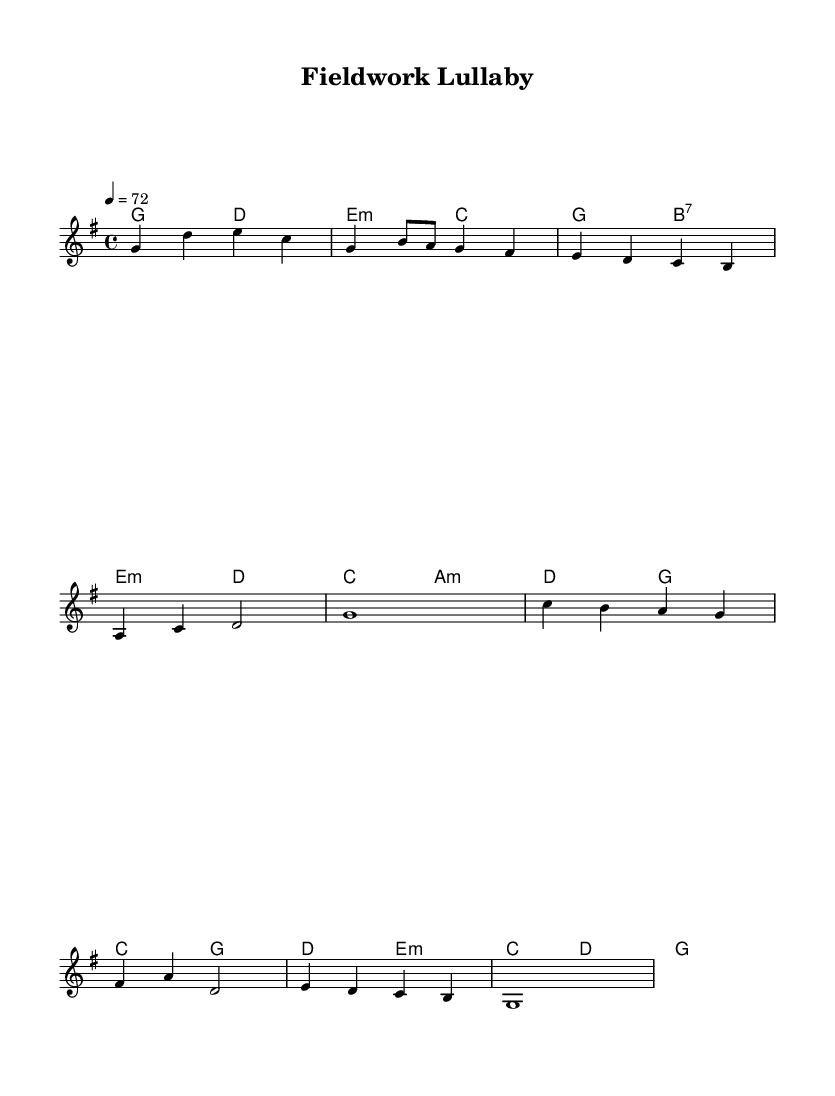What is the key signature of this music? The key signature is G major, which has one sharp (F#).
Answer: G major What is the time signature of this piece? The time signature is 4/4, meaning there are four beats per measure and a quarter note receives one beat.
Answer: 4/4 What is the tempo marking for this piece? The tempo marking is 72 beats per minute, indicating a moderate tempo.
Answer: 72 How many measures are in the chorus section? The chorus section consists of four measures, as indicated by the number of vertical lines separating the musical phrases.
Answer: 4 What type of chords are used in the first verse? The chords in the first verse include both major and minor, as seen from the chord symbols (e.g., b7 and a:min).
Answer: Major and minor What is the last note of the melody? The last note of the melody is G in the fourth measure of the chorus, sustained as a whole note.
Answer: G Which musical section follows the introduction? The verse follows the introduction, as it directly follows the introductory measures.
Answer: Verse 1 